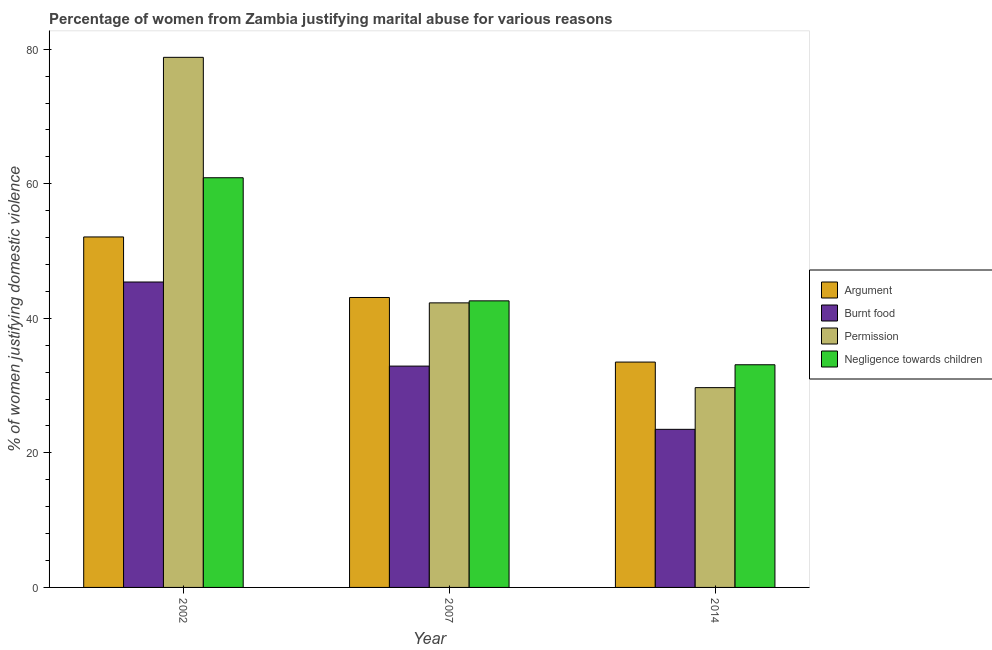How many groups of bars are there?
Make the answer very short. 3. Are the number of bars per tick equal to the number of legend labels?
Offer a very short reply. Yes. How many bars are there on the 1st tick from the left?
Give a very brief answer. 4. How many bars are there on the 2nd tick from the right?
Your response must be concise. 4. In how many cases, is the number of bars for a given year not equal to the number of legend labels?
Keep it short and to the point. 0. What is the percentage of women justifying abuse for burning food in 2007?
Provide a short and direct response. 32.9. Across all years, what is the maximum percentage of women justifying abuse for showing negligence towards children?
Provide a succinct answer. 60.9. Across all years, what is the minimum percentage of women justifying abuse for burning food?
Provide a succinct answer. 23.5. In which year was the percentage of women justifying abuse for showing negligence towards children maximum?
Make the answer very short. 2002. What is the total percentage of women justifying abuse in the case of an argument in the graph?
Give a very brief answer. 128.7. What is the difference between the percentage of women justifying abuse for going without permission in 2002 and that in 2007?
Provide a succinct answer. 36.5. What is the average percentage of women justifying abuse for going without permission per year?
Ensure brevity in your answer.  50.27. What is the ratio of the percentage of women justifying abuse in the case of an argument in 2002 to that in 2007?
Keep it short and to the point. 1.21. Is the percentage of women justifying abuse for showing negligence towards children in 2002 less than that in 2007?
Offer a very short reply. No. What is the difference between the highest and the second highest percentage of women justifying abuse for burning food?
Provide a succinct answer. 12.5. What is the difference between the highest and the lowest percentage of women justifying abuse for burning food?
Give a very brief answer. 21.9. In how many years, is the percentage of women justifying abuse in the case of an argument greater than the average percentage of women justifying abuse in the case of an argument taken over all years?
Make the answer very short. 2. Is the sum of the percentage of women justifying abuse for showing negligence towards children in 2007 and 2014 greater than the maximum percentage of women justifying abuse for going without permission across all years?
Ensure brevity in your answer.  Yes. Is it the case that in every year, the sum of the percentage of women justifying abuse in the case of an argument and percentage of women justifying abuse for showing negligence towards children is greater than the sum of percentage of women justifying abuse for burning food and percentage of women justifying abuse for going without permission?
Offer a terse response. No. What does the 1st bar from the left in 2014 represents?
Your answer should be very brief. Argument. What does the 2nd bar from the right in 2002 represents?
Your answer should be very brief. Permission. Is it the case that in every year, the sum of the percentage of women justifying abuse in the case of an argument and percentage of women justifying abuse for burning food is greater than the percentage of women justifying abuse for going without permission?
Make the answer very short. Yes. How many bars are there?
Ensure brevity in your answer.  12. Are all the bars in the graph horizontal?
Keep it short and to the point. No. How many years are there in the graph?
Keep it short and to the point. 3. Are the values on the major ticks of Y-axis written in scientific E-notation?
Offer a very short reply. No. How are the legend labels stacked?
Keep it short and to the point. Vertical. What is the title of the graph?
Ensure brevity in your answer.  Percentage of women from Zambia justifying marital abuse for various reasons. Does "Primary" appear as one of the legend labels in the graph?
Your answer should be very brief. No. What is the label or title of the Y-axis?
Offer a terse response. % of women justifying domestic violence. What is the % of women justifying domestic violence of Argument in 2002?
Your answer should be compact. 52.1. What is the % of women justifying domestic violence of Burnt food in 2002?
Your response must be concise. 45.4. What is the % of women justifying domestic violence in Permission in 2002?
Ensure brevity in your answer.  78.8. What is the % of women justifying domestic violence in Negligence towards children in 2002?
Offer a terse response. 60.9. What is the % of women justifying domestic violence of Argument in 2007?
Your answer should be compact. 43.1. What is the % of women justifying domestic violence in Burnt food in 2007?
Give a very brief answer. 32.9. What is the % of women justifying domestic violence of Permission in 2007?
Your answer should be compact. 42.3. What is the % of women justifying domestic violence in Negligence towards children in 2007?
Provide a short and direct response. 42.6. What is the % of women justifying domestic violence of Argument in 2014?
Your answer should be compact. 33.5. What is the % of women justifying domestic violence of Burnt food in 2014?
Make the answer very short. 23.5. What is the % of women justifying domestic violence of Permission in 2014?
Ensure brevity in your answer.  29.7. What is the % of women justifying domestic violence of Negligence towards children in 2014?
Make the answer very short. 33.1. Across all years, what is the maximum % of women justifying domestic violence in Argument?
Offer a very short reply. 52.1. Across all years, what is the maximum % of women justifying domestic violence of Burnt food?
Ensure brevity in your answer.  45.4. Across all years, what is the maximum % of women justifying domestic violence of Permission?
Ensure brevity in your answer.  78.8. Across all years, what is the maximum % of women justifying domestic violence of Negligence towards children?
Provide a succinct answer. 60.9. Across all years, what is the minimum % of women justifying domestic violence of Argument?
Keep it short and to the point. 33.5. Across all years, what is the minimum % of women justifying domestic violence of Permission?
Ensure brevity in your answer.  29.7. Across all years, what is the minimum % of women justifying domestic violence of Negligence towards children?
Your answer should be very brief. 33.1. What is the total % of women justifying domestic violence of Argument in the graph?
Provide a succinct answer. 128.7. What is the total % of women justifying domestic violence in Burnt food in the graph?
Your answer should be very brief. 101.8. What is the total % of women justifying domestic violence of Permission in the graph?
Your answer should be very brief. 150.8. What is the total % of women justifying domestic violence of Negligence towards children in the graph?
Provide a short and direct response. 136.6. What is the difference between the % of women justifying domestic violence of Permission in 2002 and that in 2007?
Your answer should be very brief. 36.5. What is the difference between the % of women justifying domestic violence in Negligence towards children in 2002 and that in 2007?
Your answer should be very brief. 18.3. What is the difference between the % of women justifying domestic violence of Burnt food in 2002 and that in 2014?
Offer a very short reply. 21.9. What is the difference between the % of women justifying domestic violence in Permission in 2002 and that in 2014?
Make the answer very short. 49.1. What is the difference between the % of women justifying domestic violence in Negligence towards children in 2002 and that in 2014?
Keep it short and to the point. 27.8. What is the difference between the % of women justifying domestic violence of Argument in 2007 and that in 2014?
Keep it short and to the point. 9.6. What is the difference between the % of women justifying domestic violence of Negligence towards children in 2007 and that in 2014?
Offer a terse response. 9.5. What is the difference between the % of women justifying domestic violence in Argument in 2002 and the % of women justifying domestic violence in Permission in 2007?
Ensure brevity in your answer.  9.8. What is the difference between the % of women justifying domestic violence in Permission in 2002 and the % of women justifying domestic violence in Negligence towards children in 2007?
Keep it short and to the point. 36.2. What is the difference between the % of women justifying domestic violence of Argument in 2002 and the % of women justifying domestic violence of Burnt food in 2014?
Keep it short and to the point. 28.6. What is the difference between the % of women justifying domestic violence in Argument in 2002 and the % of women justifying domestic violence in Permission in 2014?
Provide a short and direct response. 22.4. What is the difference between the % of women justifying domestic violence in Burnt food in 2002 and the % of women justifying domestic violence in Permission in 2014?
Provide a succinct answer. 15.7. What is the difference between the % of women justifying domestic violence in Permission in 2002 and the % of women justifying domestic violence in Negligence towards children in 2014?
Provide a succinct answer. 45.7. What is the difference between the % of women justifying domestic violence of Argument in 2007 and the % of women justifying domestic violence of Burnt food in 2014?
Provide a short and direct response. 19.6. What is the difference between the % of women justifying domestic violence of Argument in 2007 and the % of women justifying domestic violence of Permission in 2014?
Offer a very short reply. 13.4. What is the difference between the % of women justifying domestic violence of Burnt food in 2007 and the % of women justifying domestic violence of Permission in 2014?
Give a very brief answer. 3.2. What is the difference between the % of women justifying domestic violence of Burnt food in 2007 and the % of women justifying domestic violence of Negligence towards children in 2014?
Your response must be concise. -0.2. What is the average % of women justifying domestic violence in Argument per year?
Offer a terse response. 42.9. What is the average % of women justifying domestic violence in Burnt food per year?
Provide a succinct answer. 33.93. What is the average % of women justifying domestic violence in Permission per year?
Ensure brevity in your answer.  50.27. What is the average % of women justifying domestic violence of Negligence towards children per year?
Ensure brevity in your answer.  45.53. In the year 2002, what is the difference between the % of women justifying domestic violence of Argument and % of women justifying domestic violence of Permission?
Provide a succinct answer. -26.7. In the year 2002, what is the difference between the % of women justifying domestic violence in Argument and % of women justifying domestic violence in Negligence towards children?
Your answer should be very brief. -8.8. In the year 2002, what is the difference between the % of women justifying domestic violence of Burnt food and % of women justifying domestic violence of Permission?
Your answer should be compact. -33.4. In the year 2002, what is the difference between the % of women justifying domestic violence in Burnt food and % of women justifying domestic violence in Negligence towards children?
Your answer should be very brief. -15.5. In the year 2002, what is the difference between the % of women justifying domestic violence of Permission and % of women justifying domestic violence of Negligence towards children?
Give a very brief answer. 17.9. In the year 2007, what is the difference between the % of women justifying domestic violence of Argument and % of women justifying domestic violence of Burnt food?
Offer a very short reply. 10.2. In the year 2007, what is the difference between the % of women justifying domestic violence of Argument and % of women justifying domestic violence of Negligence towards children?
Keep it short and to the point. 0.5. In the year 2007, what is the difference between the % of women justifying domestic violence of Burnt food and % of women justifying domestic violence of Permission?
Your answer should be compact. -9.4. In the year 2007, what is the difference between the % of women justifying domestic violence in Permission and % of women justifying domestic violence in Negligence towards children?
Keep it short and to the point. -0.3. In the year 2014, what is the difference between the % of women justifying domestic violence of Burnt food and % of women justifying domestic violence of Permission?
Provide a succinct answer. -6.2. What is the ratio of the % of women justifying domestic violence of Argument in 2002 to that in 2007?
Keep it short and to the point. 1.21. What is the ratio of the % of women justifying domestic violence of Burnt food in 2002 to that in 2007?
Make the answer very short. 1.38. What is the ratio of the % of women justifying domestic violence in Permission in 2002 to that in 2007?
Provide a succinct answer. 1.86. What is the ratio of the % of women justifying domestic violence in Negligence towards children in 2002 to that in 2007?
Your answer should be compact. 1.43. What is the ratio of the % of women justifying domestic violence of Argument in 2002 to that in 2014?
Your response must be concise. 1.56. What is the ratio of the % of women justifying domestic violence of Burnt food in 2002 to that in 2014?
Provide a short and direct response. 1.93. What is the ratio of the % of women justifying domestic violence in Permission in 2002 to that in 2014?
Provide a succinct answer. 2.65. What is the ratio of the % of women justifying domestic violence in Negligence towards children in 2002 to that in 2014?
Your response must be concise. 1.84. What is the ratio of the % of women justifying domestic violence of Argument in 2007 to that in 2014?
Provide a short and direct response. 1.29. What is the ratio of the % of women justifying domestic violence of Permission in 2007 to that in 2014?
Provide a short and direct response. 1.42. What is the ratio of the % of women justifying domestic violence of Negligence towards children in 2007 to that in 2014?
Give a very brief answer. 1.29. What is the difference between the highest and the second highest % of women justifying domestic violence of Argument?
Keep it short and to the point. 9. What is the difference between the highest and the second highest % of women justifying domestic violence of Permission?
Provide a short and direct response. 36.5. What is the difference between the highest and the second highest % of women justifying domestic violence of Negligence towards children?
Make the answer very short. 18.3. What is the difference between the highest and the lowest % of women justifying domestic violence in Argument?
Your response must be concise. 18.6. What is the difference between the highest and the lowest % of women justifying domestic violence of Burnt food?
Your answer should be very brief. 21.9. What is the difference between the highest and the lowest % of women justifying domestic violence in Permission?
Give a very brief answer. 49.1. What is the difference between the highest and the lowest % of women justifying domestic violence in Negligence towards children?
Provide a succinct answer. 27.8. 